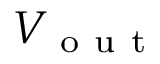Convert formula to latex. <formula><loc_0><loc_0><loc_500><loc_500>V _ { o u t }</formula> 